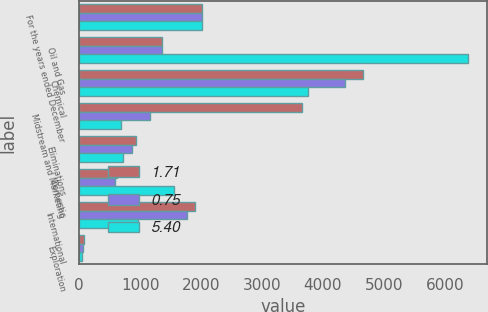Convert chart to OTSL. <chart><loc_0><loc_0><loc_500><loc_500><stacked_bar_chart><ecel><fcel>For the years ended December<fcel>Oil and Gas<fcel>Chemical<fcel>Midstream and Marketing<fcel>Eliminations<fcel>Domestic<fcel>International<fcel>Exploration<nl><fcel>1.71<fcel>2018<fcel>1354.5<fcel>4657<fcel>3656<fcel>930<fcel>621<fcel>1896<fcel>75<nl><fcel>0.75<fcel>2017<fcel>1354.5<fcel>4355<fcel>1157<fcel>874<fcel>589<fcel>1767<fcel>67<nl><fcel>5.4<fcel>2016<fcel>6377<fcel>3756<fcel>684<fcel>727<fcel>1552<fcel>965<fcel>49<nl></chart> 